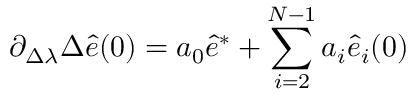<formula> <loc_0><loc_0><loc_500><loc_500>\partial _ { \Delta \lambda } \Delta \hat { e } ( 0 ) = a _ { 0 } \hat { e } ^ { * } + \sum _ { i = 2 } ^ { N - 1 } a _ { i } \hat { e } _ { i } ( 0 )</formula> 